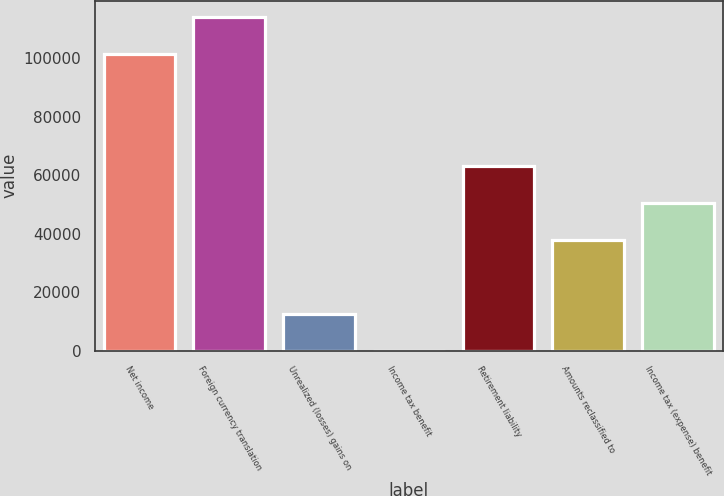<chart> <loc_0><loc_0><loc_500><loc_500><bar_chart><fcel>Net income<fcel>Foreign currency translation<fcel>Unrealized (losses) gains on<fcel>Income tax benefit<fcel>Retirement liability<fcel>Amounts reclassified to<fcel>Income tax (expense) benefit<nl><fcel>101233<fcel>113878<fcel>12713.6<fcel>68<fcel>63296<fcel>38004.8<fcel>50650.4<nl></chart> 